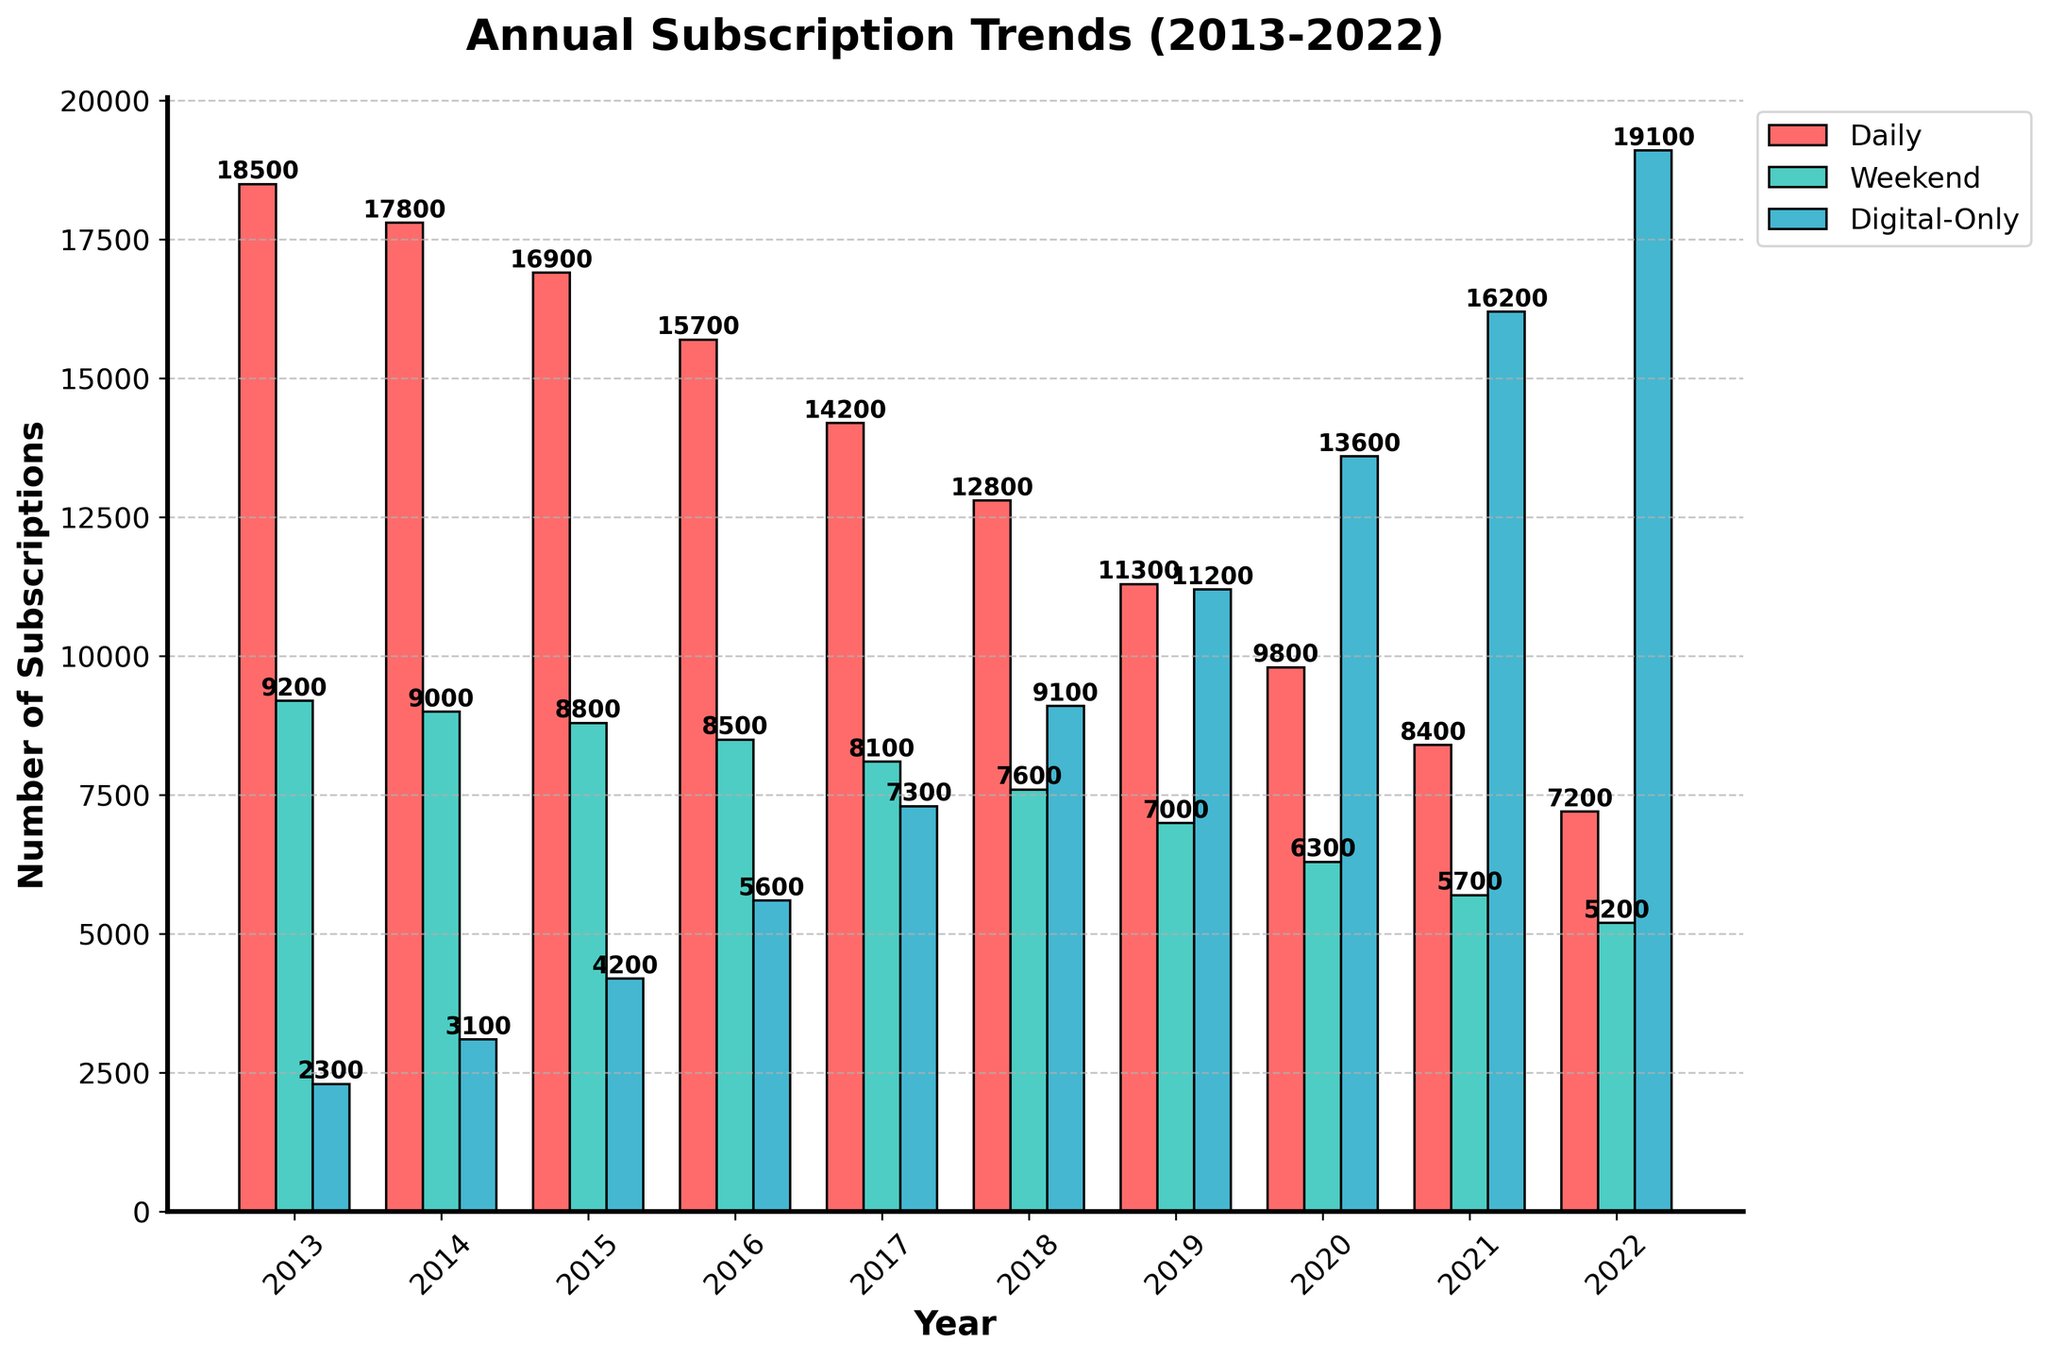What was the trend in daily subscriptions from 2013 to 2022? Observing the heights of the red bars from left to right, you can see they are decreasing each year. Thus, the trend in daily subscriptions is a continuous decline from 2013 to 2022.
Answer: Continuous decline Which year had the highest number of digital-only subscriptions? By looking for the tallest blue bar in the chart, you can see that it is in the year 2022. Therefore, the year with the highest number of digital-only subscriptions is 2022.
Answer: 2022 In which year was the difference between weekend and daily subscriptions the greatest? Firstly, compute the difference between the weekend and daily subscriptions for each year. For example, in 2013: 18500 - 9200 = 9300. Performing this calculation for every year and comparing values, the largest difference occurs in 2013.
Answer: 2013 What is the combined total number of daily and weekend subscriptions in 2018? Summing the red bar (12800) and the green bar (7600) for the year 2018: 12800 + 7600 = 20400.
Answer: 20400 Which year saw an equal number of daily and weekend subscriptions? Comparing the heights of the red and green bars, none of the years show bars of equal height. Thus, there isn't a year with equal numbers of daily and weekend subscriptions.
Answer: None How much did digital-only subscriptions increase from 2015 to 2022? Finding the digital-only subscriptions for 2015 and 2022 (4200 and 19100, respectively), then compute the difference: 19100 - 4200 = 14900.
Answer: 14900 Between 2013 and 2022, which type of subscription saw the most growth? By comparing the change in height for each type of subscription bar from 2013 to 2022, it is clear that the blue bar (digital-only) grew while both the red (daily) and green (weekend) declined. Therefore, digital-only subscriptions saw the most growth.
Answer: Digital-only What was the percentage drop in daily subscriptions from 2013 to 2022? Compute the initial value (18500) and the final value (7200), then find the drop: 18500 - 7200 = 11300. The percentage drop is (11300 / 18500) * 100 = 61.08%.
Answer: 61.08% Which subscription type was the most consistent in terms of changes over the years? Observing the bars, the green bar (weekend subscriptions) shows the most gradual and least steep changes over the years, indicating it was the most consistent.
Answer: Weekend 